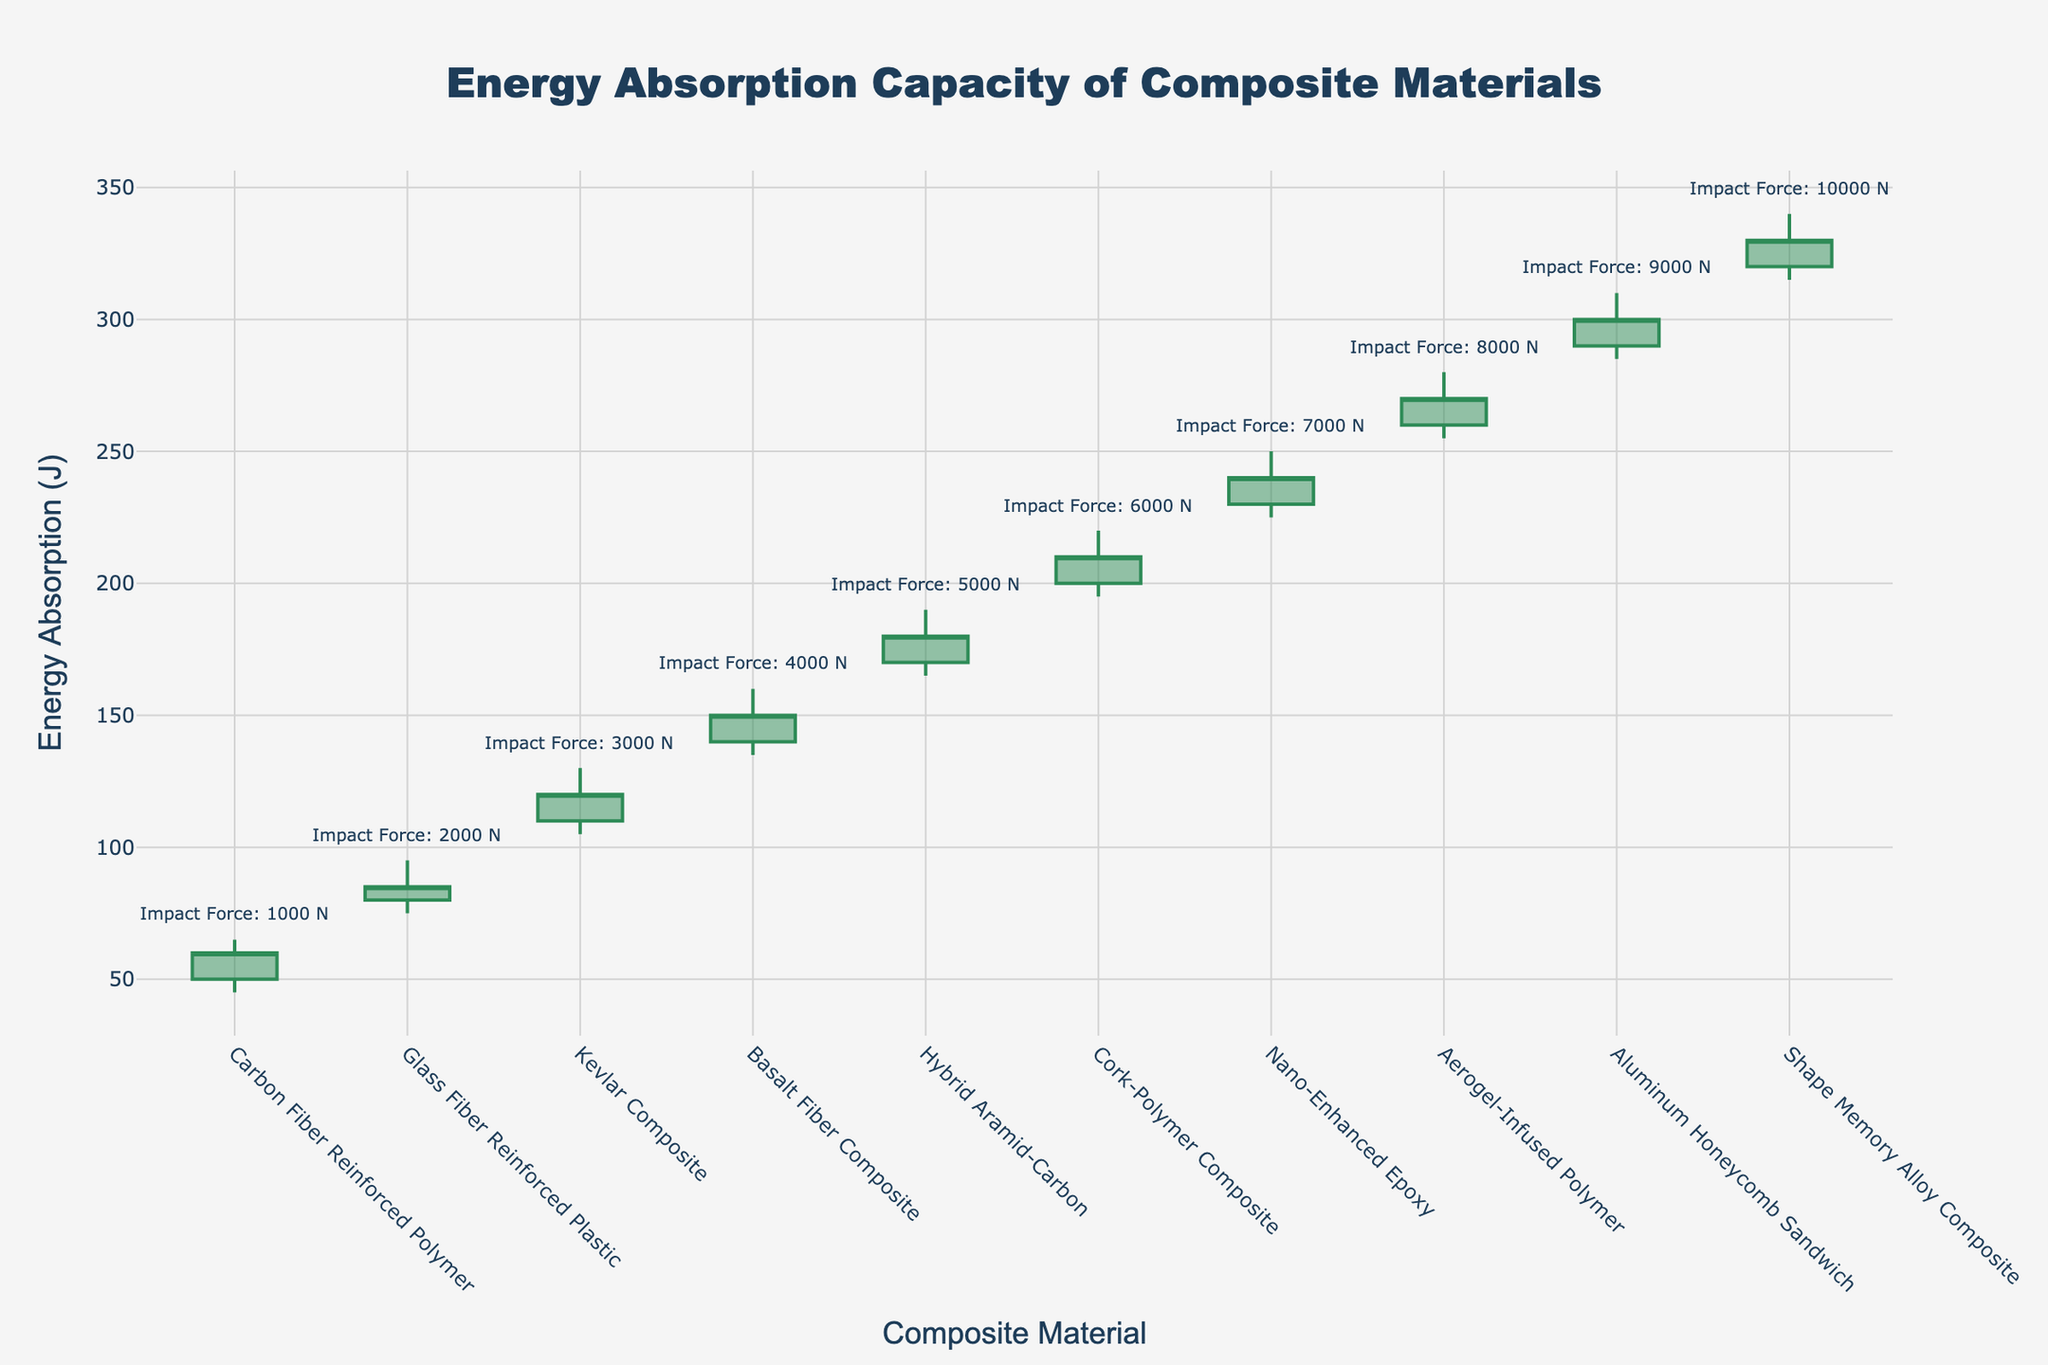What is the title of the figure? The title is typically located at the top center of the figure. In this case, the title of the figure is "Energy Absorption Capacity of Composite Materials".
Answer: Energy Absorption Capacity of Composite Materials How many composite materials are displayed in the plot? To find the number of composite materials, count the distinct x-ticks (categories) on the x-axis of the plot. There are 10 materials listed from "Carbon Fiber Reinforced Polymer" to "Shape Memory Alloy Composite".
Answer: 10 Which material exhibits the highest energy absorption, and what is the corresponding value? Identify the material with the highest "High (J)" value by scanning the highest peak on the y-axis. The "Shape Memory Alloy Composite" has the highest energy absorption with a "High (J)" value of 340 J.
Answer: Shape Memory Alloy Composite, 340 J What is the energy absorption range for the Kevlar Composite? The energy absorption range can be calculated by subtracting the "Low (J)" value from the "High (J)" value for the material. For Kevlar Composite, it's from 130 J (High) to 105 J (Low). So, the range is 130 - 105 = 25 J.
Answer: 25 J Which material shows the most significant difference between open and close energy absorption values? To find this, calculate the difference between the "Open (J)" and "Close (J)" values for each material and identify the largest difference. For Cork-Polymer Composite, the difference is 210 J (Close) - 200 J (Open) = 10 J, which is the largest observed difference.
Answer: Cork-Polymer Composite For which impact force is the low energy absorption the highest, and what is the value? Check the "Low (J)" values and identify the highest one. The impact force associated with the highest "Low (J)" is for "Shape Memory Alloy Composite" with a value of 315 J.
Answer: 315 J Between Basalt Fiber Composite and Hybrid Aramid-Carbon, which material has the higher average energy absorption, and what are their average values? Calculate the average energy absorption ((Open + High + Low + Close)/4) for both materials. For Basalt Fiber Composite: (140 + 160 + 135 + 150)/4 = 146.25 J, and for Hybrid Aramid-Carbon: (170 + 190 + 165 + 180)/4 = 176.25 J. Hybrid Aramid-Carbon has the higher average.
Answer: Hybrid Aramid-Carbon, 176.25 J Does the energy absorption of Aluminum Honeycomb Sandwich increase or decrease from open to close? Compare the "Open (J)" and "Close (J)" values for Aluminum Honeycomb Sandwich. The "Open (J)" is 290 J and the "Close (J)" is 300 J, indicating an increase.
Answer: Increase Which material has the smallest range in energy absorption, and what is the range? Calculate the range (High - Low) for each material and identify the smallest one. For Glass Fiber Reinforced Plastic, the range is 95 J (High) - 75 J (Low) = 20 J, which is the smallest range.
Answer: Glass Fiber Reinforced Plastic, 20 J What is the color used for increasing energy absorption lines? Based on the figure's description, by checking the line color for increasing points, the color is a shade of green.
Answer: Green 